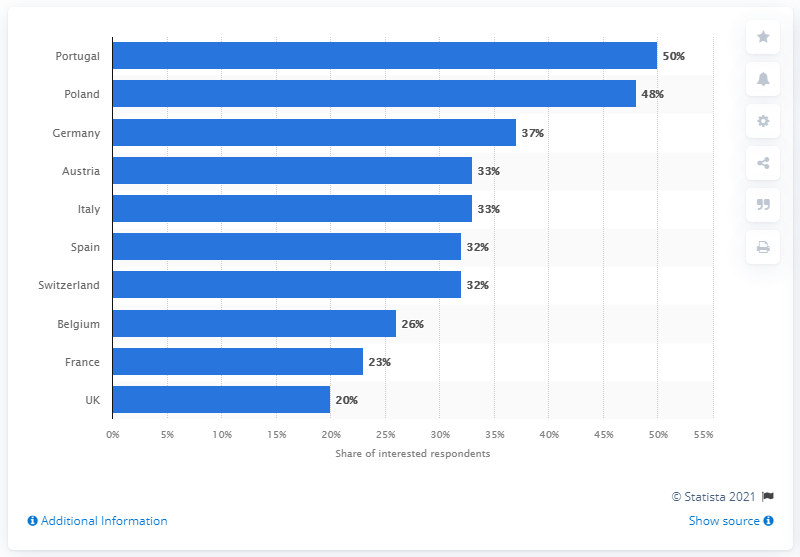Identify some key points in this picture. The country that demonstrated the greatest interest in traveling to attend the UEFA European Football Championship in 2020 was Portugal. 